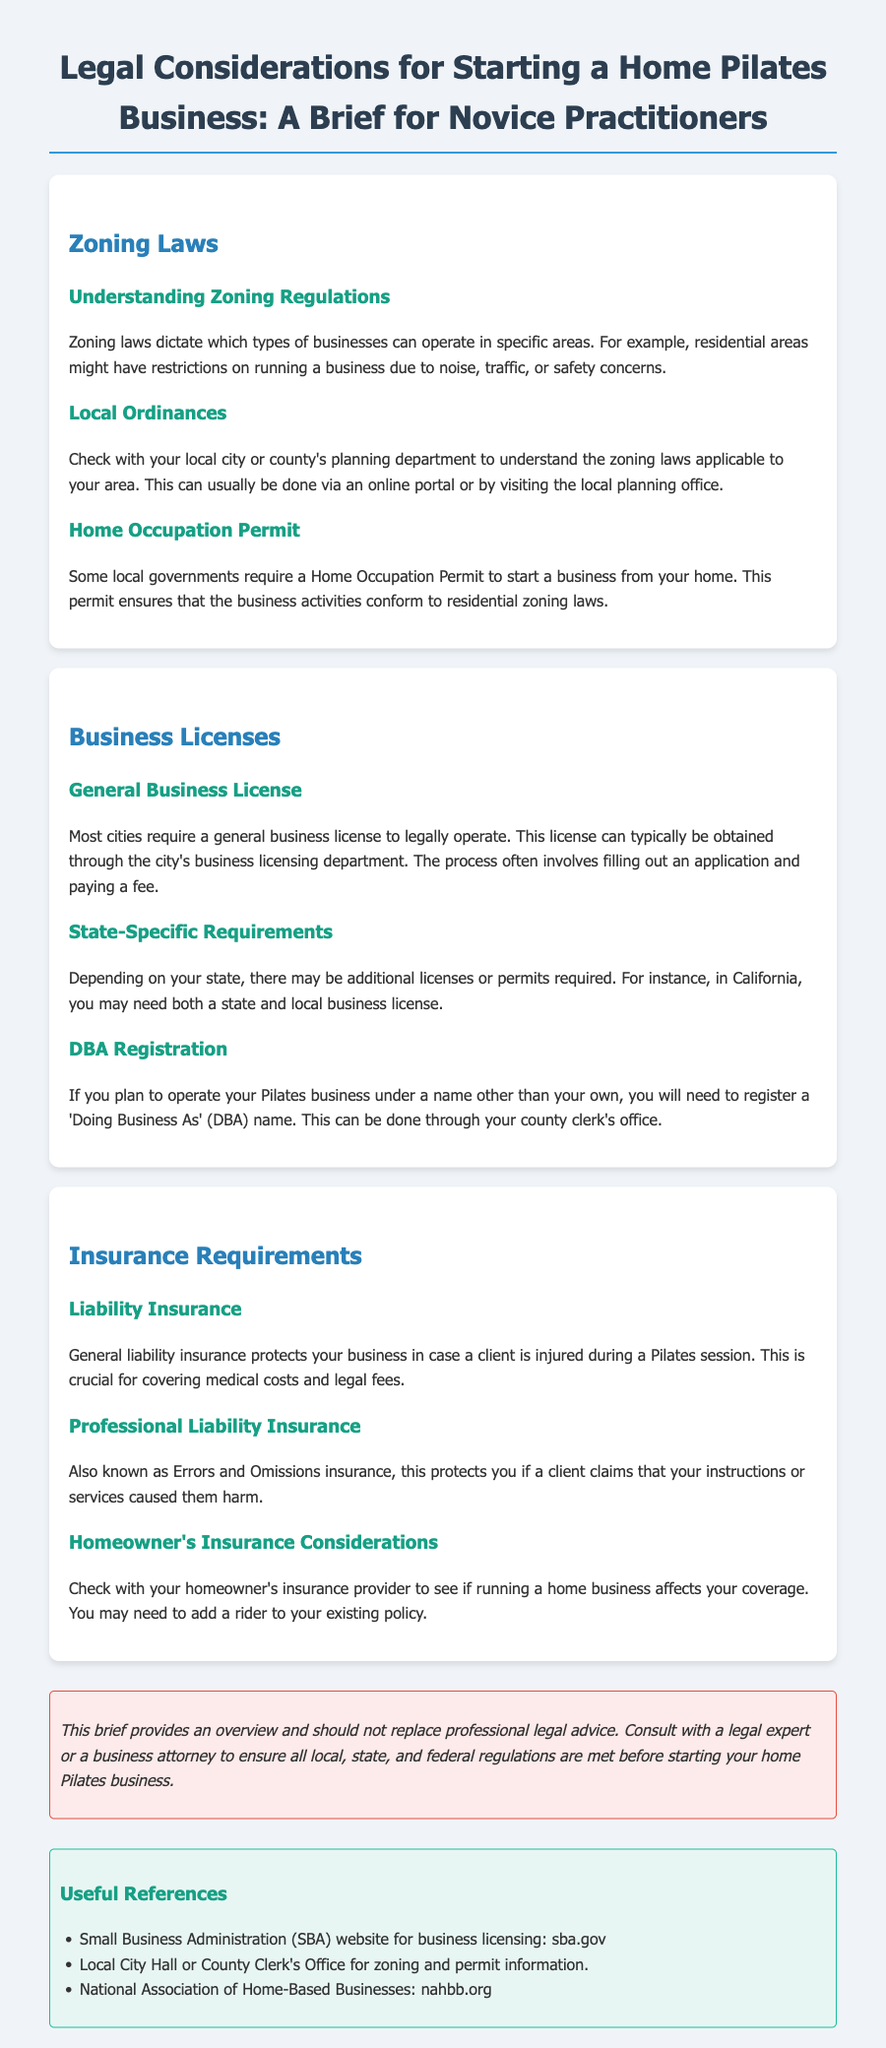What do zoning laws dictate? Zoning laws dictate which types of businesses can operate in specific areas.
Answer: Types of businesses What is required to operate a business from home according to some local governments? Some local governments require a Home Occupation Permit to start a business from your home.
Answer: Home Occupation Permit Where can you obtain a general business license? This license can typically be obtained through the city's business licensing department.
Answer: City's business licensing department What type of insurance protects against client injury during sessions? General liability insurance protects your business in case a client is injured during a Pilates session.
Answer: General liability insurance What might you need to add to your homeowner's insurance policy? You may need to add a rider to your existing policy.
Answer: Rider What kind of insurance protects you against claims of harm from your services? This protects you if a client claims that your instructions or services caused them harm.
Answer: Professional liability insurance Which organization provides information about business licensing? Small Business Administration (SBA) provides information about business licensing.
Answer: Small Business Administration (SBA) What is the purpose of a Business License? A general business license is required to legally operate.
Answer: Legally operate What does the disclaimer emphasize about the brief? The disclaimer emphasizes that the brief provides an overview and should not replace professional legal advice.
Answer: Overview and legal advice Which department should you check for zoning laws? Check with your local city or county's planning department for zoning laws.
Answer: Local city or county's planning department 